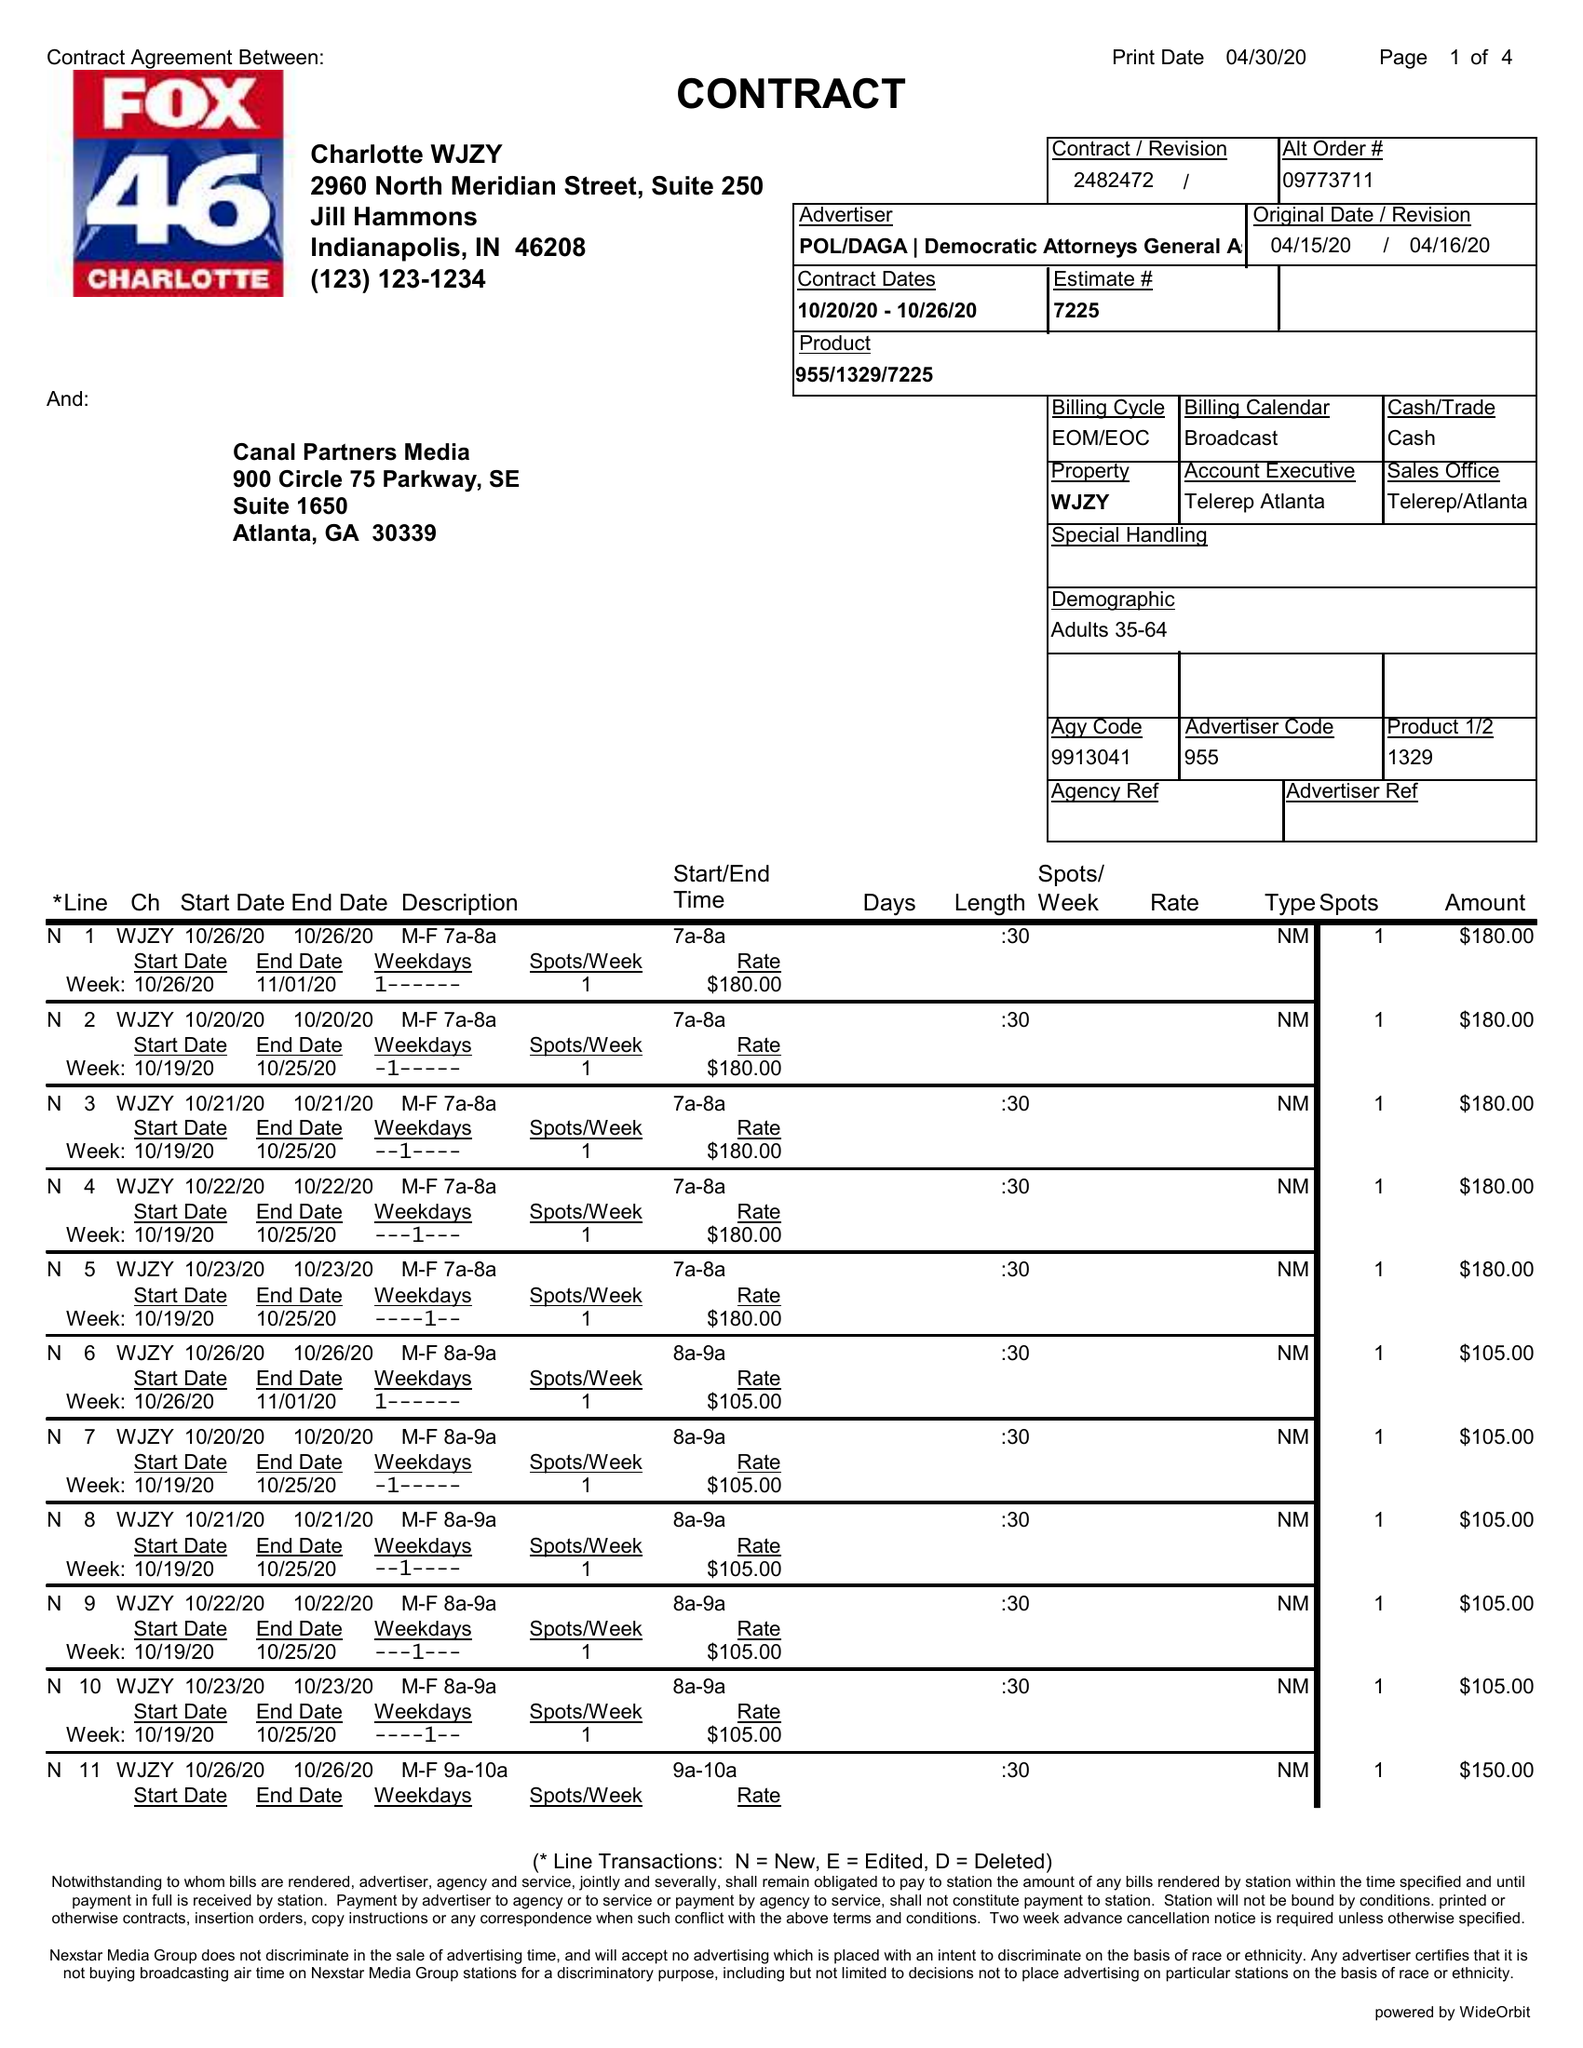What is the value for the flight_from?
Answer the question using a single word or phrase. 10/20/20 